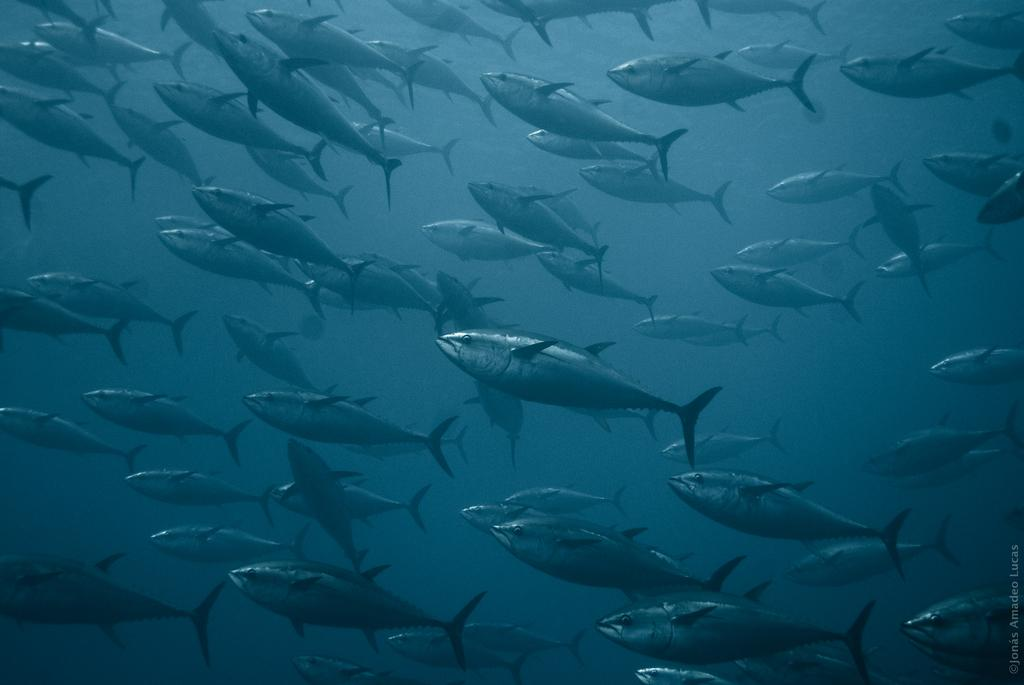What type of animals can be seen in the image? There are fish in the water. Is there any text or marking in the image? Yes, there is a watermark in the bottom right corner of the image. What color is the background of the water? The background color of the water is gray. What type of furniture can be seen in the bedroom in the image? There is no bedroom or furniture present in the image; it features fish in the water. What type of border is around the image? The image does not show any borders; it only shows fish in the water. 